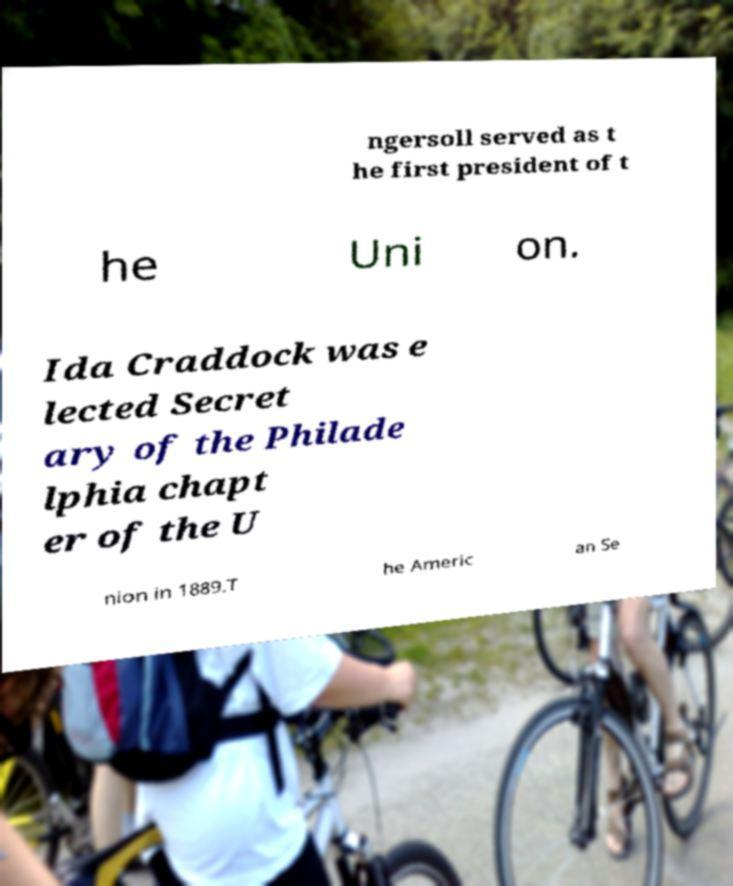Could you assist in decoding the text presented in this image and type it out clearly? ngersoll served as t he first president of t he Uni on. Ida Craddock was e lected Secret ary of the Philade lphia chapt er of the U nion in 1889.T he Americ an Se 